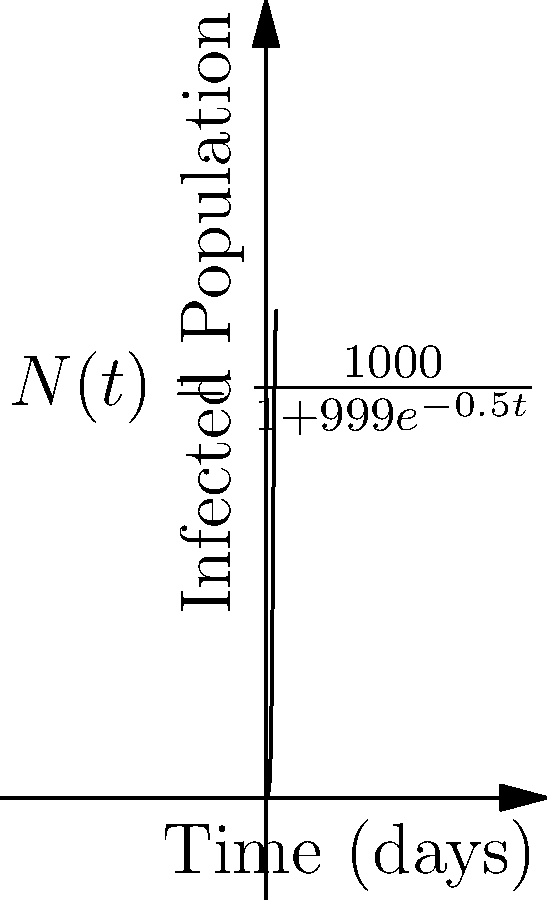A virus is spreading through a population of 1000 people. The number of infected individuals over time can be modeled by the logistic function:

$$ N(t) = \frac{1000}{1+999e^{-0.5t}} $$

where $N(t)$ is the number of infected individuals at time $t$ (in days). What is the probability that a randomly selected person from the population will be infected after 10 days? Round your answer to three decimal places. To solve this problem, we need to follow these steps:

1) First, we need to calculate the number of infected individuals after 10 days. We can do this by plugging $t=10$ into our logistic function:

   $$ N(10) = \frac{1000}{1+999e^{-0.5(10)}} $$

2) Let's calculate this:
   $$ N(10) = \frac{1000}{1+999e^{-5}} = \frac{1000}{1+999(0.00673795)} = \frac{1000}{7.73162} = 129.34 $$

3) This means that after 10 days, approximately 129 people will be infected.

4) To find the probability that a randomly selected person is infected, we divide the number of infected people by the total population:

   $$ P(\text{infected}) = \frac{\text{Number of infected}}{\text{Total population}} = \frac{129.34}{1000} = 0.12934 $$

5) Rounding to three decimal places, we get 0.129.
Answer: 0.129 